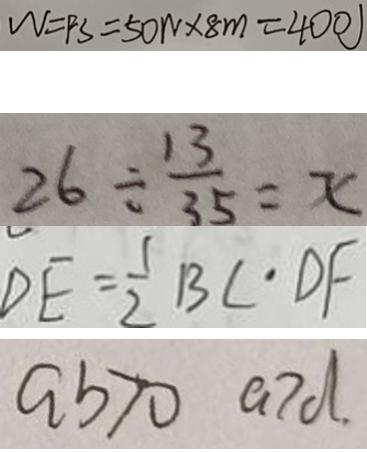<formula> <loc_0><loc_0><loc_500><loc_500>W = F S = 5 0 W \times 8 m = 4 0 0 ) 
 2 6 \div \frac { 1 3 } { 3 5 } = x 
 D E = \frac { 1 } { 2 } B C \cdot D F 
 a b > 0 a > d .</formula> 